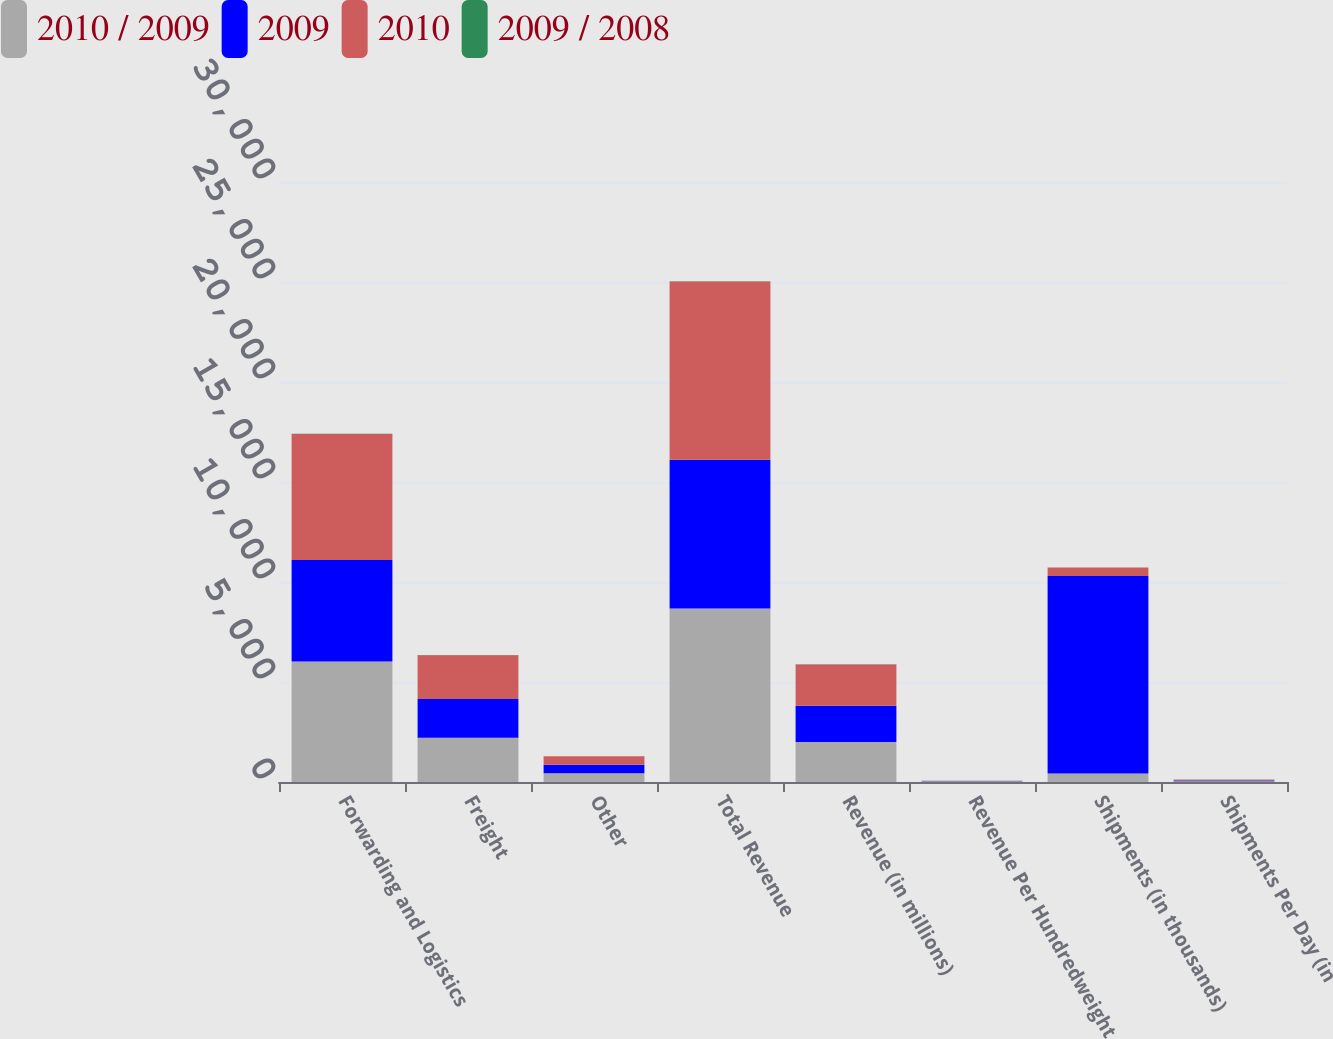Convert chart. <chart><loc_0><loc_0><loc_500><loc_500><stacked_bar_chart><ecel><fcel>Forwarding and Logistics<fcel>Freight<fcel>Other<fcel>Total Revenue<fcel>Revenue (in millions)<fcel>Revenue Per Hundredweight<fcel>Shipments (in thousands)<fcel>Shipments Per Day (in<nl><fcel>2010 / 2009<fcel>6022<fcel>2208<fcel>440<fcel>8670<fcel>2002<fcel>19.18<fcel>424<fcel>39.5<nl><fcel>2009<fcel>5080<fcel>1943<fcel>417<fcel>7440<fcel>1807<fcel>17.69<fcel>9880<fcel>39.1<nl><fcel>2010<fcel>6293<fcel>2191<fcel>431<fcel>8915<fcel>2062<fcel>18.68<fcel>424<fcel>39.5<nl><fcel>2009 / 2008<fcel>18.5<fcel>13.6<fcel>5.5<fcel>16.5<fcel>10.8<fcel>8.4<fcel>0.7<fcel>1<nl></chart> 